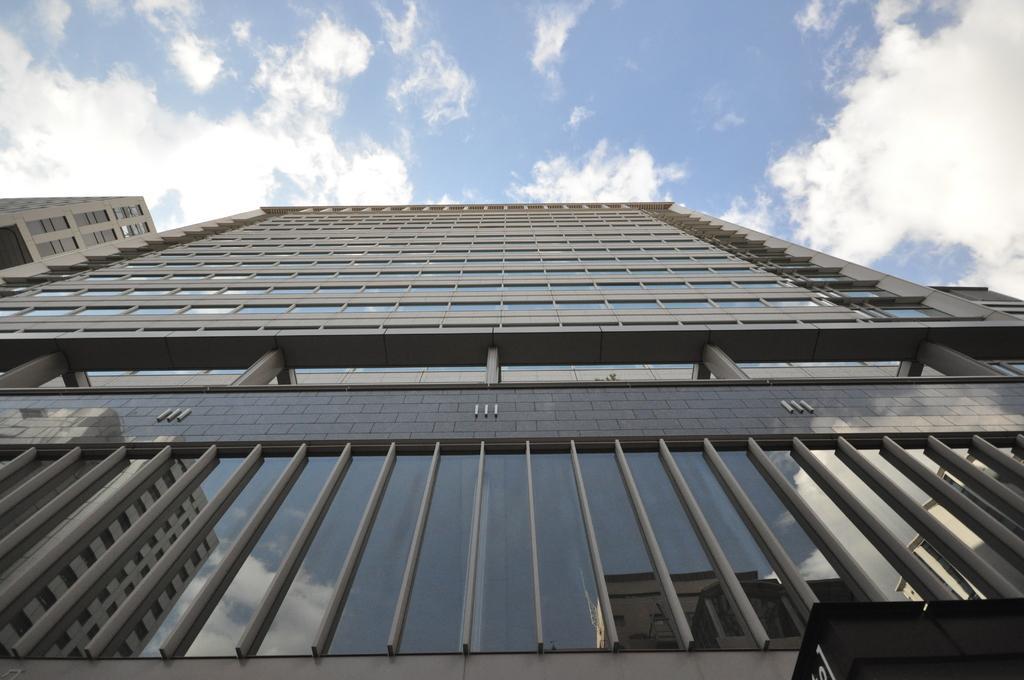Can you describe this image briefly? In this image, we can see buildings. At the top, there are clouds in the sky. 